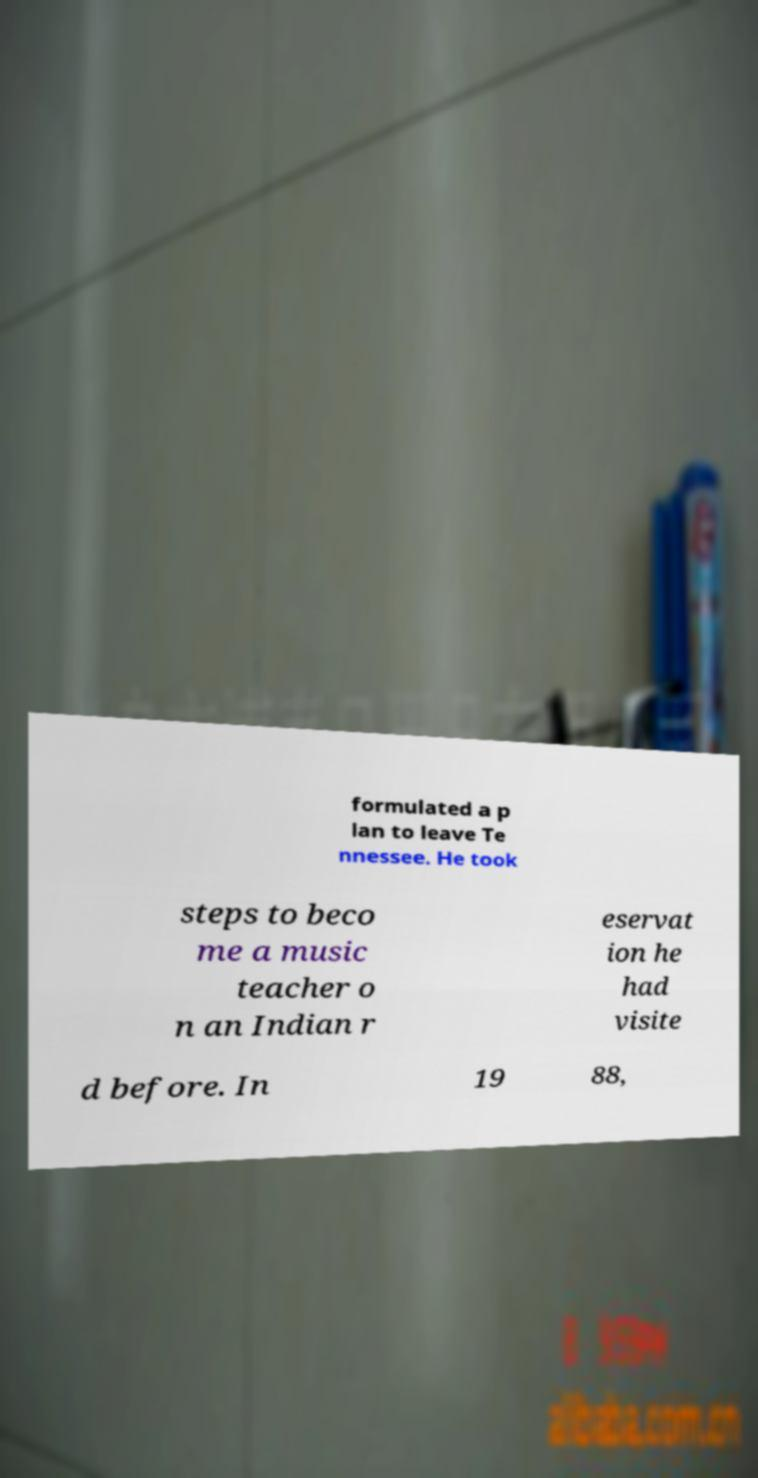What messages or text are displayed in this image? I need them in a readable, typed format. formulated a p lan to leave Te nnessee. He took steps to beco me a music teacher o n an Indian r eservat ion he had visite d before. In 19 88, 